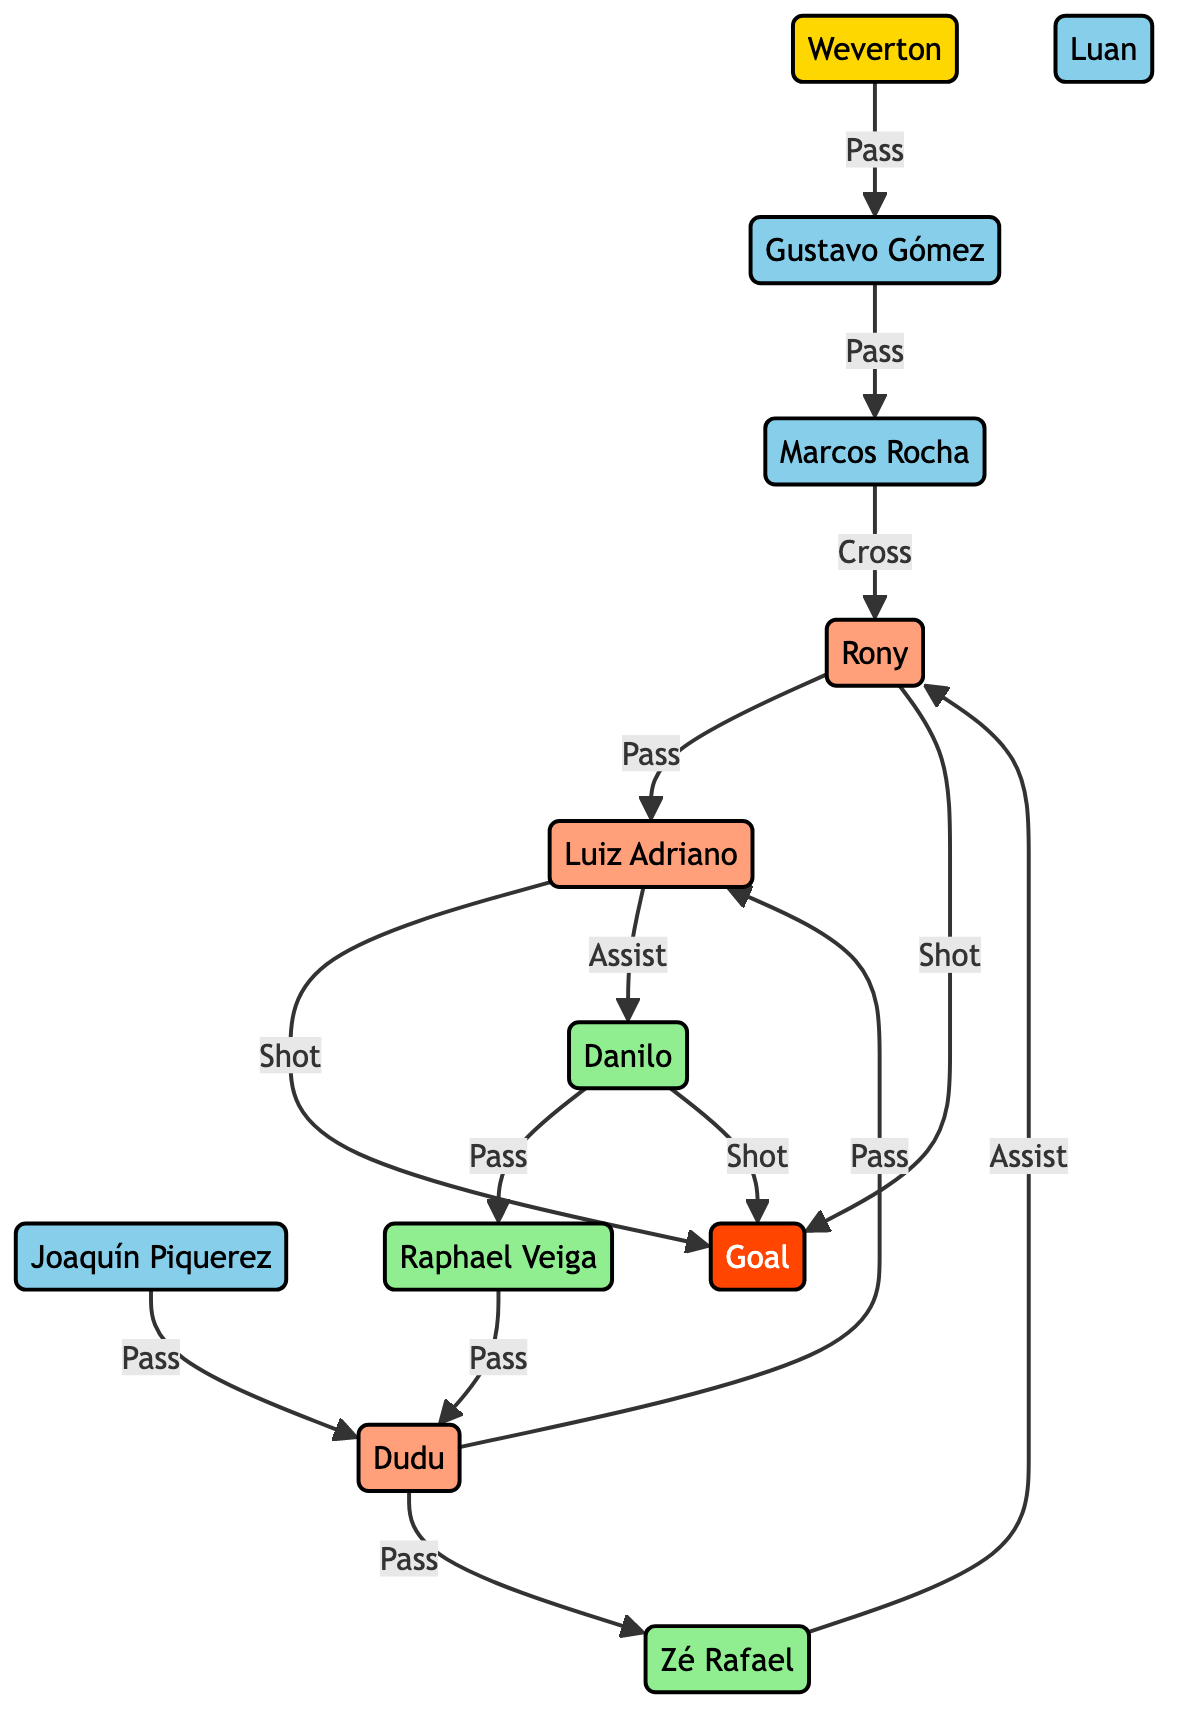What is the total number of nodes in this network diagram? The diagram lists distinct players and one goal as nodes. Counting these, we have one goalkeeper, four defenders, three midfielders, and three forwards, which totals to eleven nodes.
Answer: eleven Who assisted the shot made by Rony? In the diagram, Rony received an assist from Zé Rafael before taking the shot at goal. This is directly indicated by the edge labeled "Assist" going from Zé Rafael to Rony.
Answer: Zé Rafael How many passes were made before the first goal? The first goal followed a series of passes initiating from Weverton to Gustavo Gómez, then to Marcos Rocha, followed by a cross to Rony, who passed to Luiz Adriano, who shot the goal. Therefore, four passes were made before the first goal.
Answer: four Which player had the highest number of interactions? By reviewing the diagram, Dudu appears multiple times as a recipient of passes leading to different plays. Dudu is involved in three interactions. Other players have fewer direct interactions leading to shots, making Dudu the most involved player.
Answer: Dudu From which player did the shot for the second goal originate? The second goal was scored as a shot taken by Danilo after he received an assist from Luiz Adriano. The direct edge labeled "Assist" from Luiz Adriano to Danilo shows this relationship clearly.
Answer: Danilo What position does Marcos Rocha play? Within the diagram, Marcos Rocha is labeled as a Right Back, which is evident from the node describing his position.
Answer: Right Back Which interaction links Rony to the goal? The interaction is labeled "Shot," connecting Rony directly to the Goal after receiving a pass from Zé Rafael. This establishes the direct connection of Rony to the goal-scoring event.
Answer: Shot How many goals were scored by Palmeiras according to the diagram? The diagram indicates three distinct events leading to goals, represented by Rony's shots and Danilo's shot. Therefore, Palmares scored two goals in the illustrated sequence.
Answer: two 